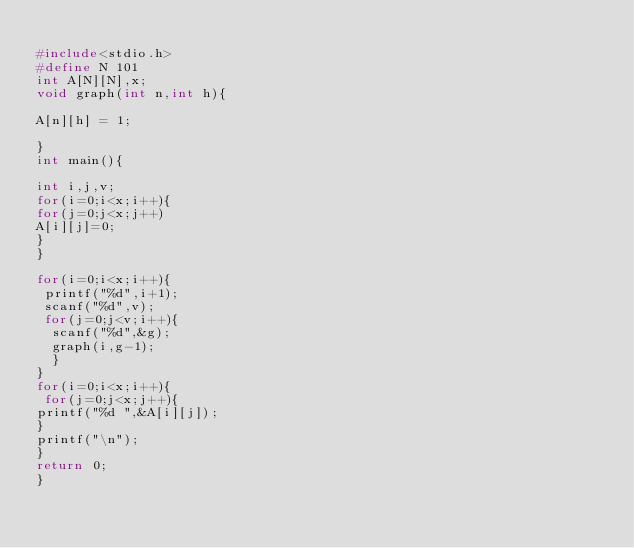Convert code to text. <code><loc_0><loc_0><loc_500><loc_500><_C_>
#include<stdio.h>
#define N 101
int A[N][N],x;
void graph(int n,int h){

A[n][h] = 1;

}
int main(){

int i,j,v;
for(i=0;i<x;i++){
for(j=0;j<x;j++)
A[i][j]=0;
}
}

for(i=0;i<x;i++){
 printf("%d",i+1);
 scanf("%d",v);
 for(j=0;j<v;i++){
  scanf("%d",&g);
  graph(i,g-1);
  }
}
for(i=0;i<x;i++){
 for(j=0;j<x;j++){
printf("%d ",&A[i][j]);
}
printf("\n");
}
return 0;
}</code> 